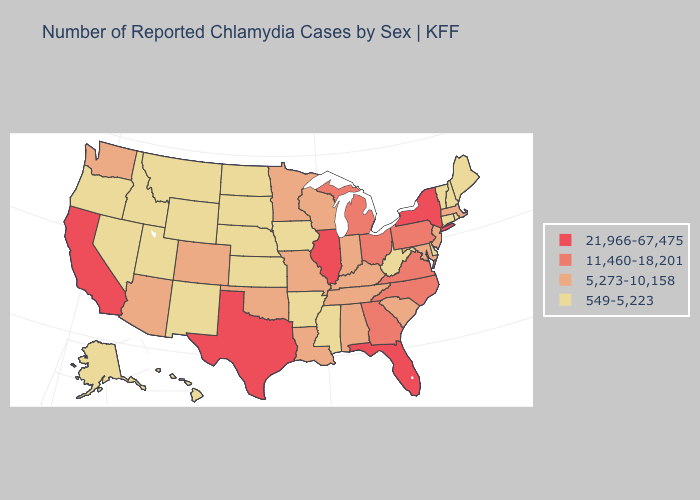What is the lowest value in states that border South Carolina?
Keep it brief. 11,460-18,201. Which states have the lowest value in the USA?
Write a very short answer. Alaska, Arkansas, Connecticut, Delaware, Hawaii, Idaho, Iowa, Kansas, Maine, Mississippi, Montana, Nebraska, Nevada, New Hampshire, New Mexico, North Dakota, Oregon, Rhode Island, South Dakota, Utah, Vermont, West Virginia, Wyoming. Name the states that have a value in the range 11,460-18,201?
Concise answer only. Georgia, Michigan, North Carolina, Ohio, Pennsylvania, Virginia. Does New York have the highest value in the USA?
Give a very brief answer. Yes. What is the highest value in the USA?
Write a very short answer. 21,966-67,475. Name the states that have a value in the range 549-5,223?
Keep it brief. Alaska, Arkansas, Connecticut, Delaware, Hawaii, Idaho, Iowa, Kansas, Maine, Mississippi, Montana, Nebraska, Nevada, New Hampshire, New Mexico, North Dakota, Oregon, Rhode Island, South Dakota, Utah, Vermont, West Virginia, Wyoming. What is the value of Missouri?
Quick response, please. 5,273-10,158. Does Maryland have the same value as Tennessee?
Answer briefly. Yes. Does the first symbol in the legend represent the smallest category?
Quick response, please. No. Among the states that border Missouri , does Kentucky have the highest value?
Quick response, please. No. Among the states that border North Carolina , does Virginia have the lowest value?
Be succinct. No. What is the value of Louisiana?
Be succinct. 5,273-10,158. What is the highest value in the USA?
Quick response, please. 21,966-67,475. Does New York have the lowest value in the USA?
Write a very short answer. No. Which states have the lowest value in the USA?
Keep it brief. Alaska, Arkansas, Connecticut, Delaware, Hawaii, Idaho, Iowa, Kansas, Maine, Mississippi, Montana, Nebraska, Nevada, New Hampshire, New Mexico, North Dakota, Oregon, Rhode Island, South Dakota, Utah, Vermont, West Virginia, Wyoming. 